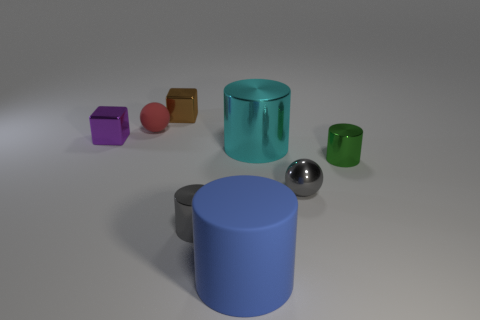Could you tell me what the large blue matte thing is made of? The large blue matte object seems to be a cylinder made of a plastic or synthetic material, characterized by its non-reflective surface and uniform shade. 